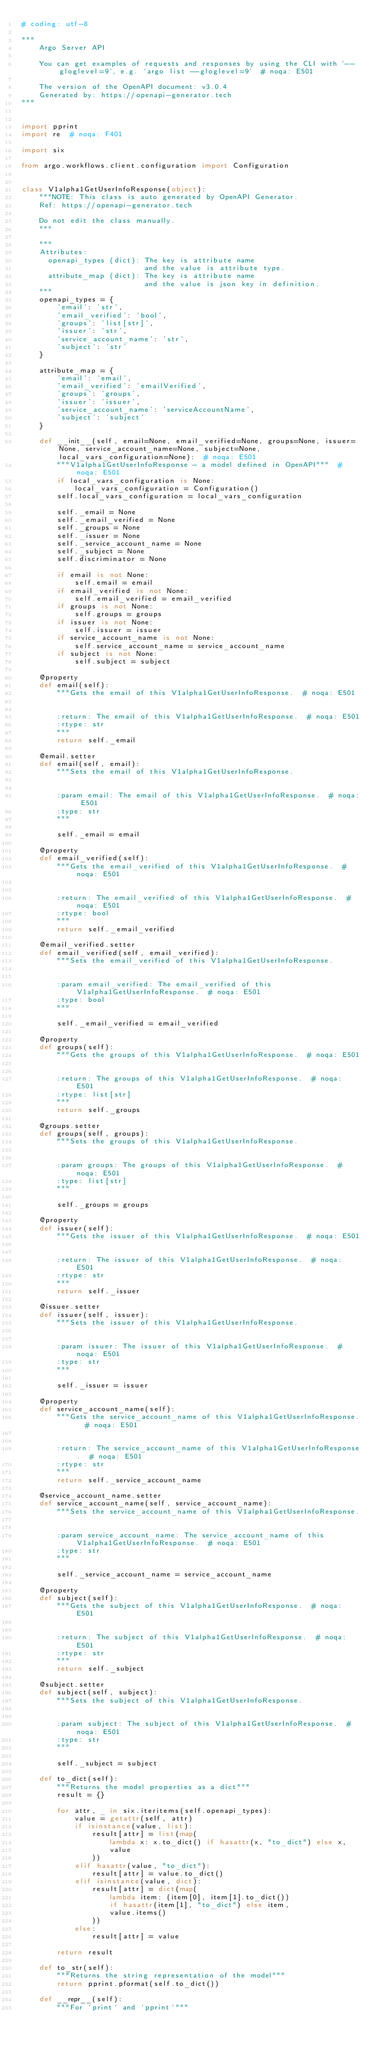Convert code to text. <code><loc_0><loc_0><loc_500><loc_500><_Python_># coding: utf-8

"""
    Argo Server API

    You can get examples of requests and responses by using the CLI with `--gloglevel=9`, e.g. `argo list --gloglevel=9`  # noqa: E501

    The version of the OpenAPI document: v3.0.4
    Generated by: https://openapi-generator.tech
"""


import pprint
import re  # noqa: F401

import six

from argo.workflows.client.configuration import Configuration


class V1alpha1GetUserInfoResponse(object):
    """NOTE: This class is auto generated by OpenAPI Generator.
    Ref: https://openapi-generator.tech

    Do not edit the class manually.
    """

    """
    Attributes:
      openapi_types (dict): The key is attribute name
                            and the value is attribute type.
      attribute_map (dict): The key is attribute name
                            and the value is json key in definition.
    """
    openapi_types = {
        'email': 'str',
        'email_verified': 'bool',
        'groups': 'list[str]',
        'issuer': 'str',
        'service_account_name': 'str',
        'subject': 'str'
    }

    attribute_map = {
        'email': 'email',
        'email_verified': 'emailVerified',
        'groups': 'groups',
        'issuer': 'issuer',
        'service_account_name': 'serviceAccountName',
        'subject': 'subject'
    }

    def __init__(self, email=None, email_verified=None, groups=None, issuer=None, service_account_name=None, subject=None, local_vars_configuration=None):  # noqa: E501
        """V1alpha1GetUserInfoResponse - a model defined in OpenAPI"""  # noqa: E501
        if local_vars_configuration is None:
            local_vars_configuration = Configuration()
        self.local_vars_configuration = local_vars_configuration

        self._email = None
        self._email_verified = None
        self._groups = None
        self._issuer = None
        self._service_account_name = None
        self._subject = None
        self.discriminator = None

        if email is not None:
            self.email = email
        if email_verified is not None:
            self.email_verified = email_verified
        if groups is not None:
            self.groups = groups
        if issuer is not None:
            self.issuer = issuer
        if service_account_name is not None:
            self.service_account_name = service_account_name
        if subject is not None:
            self.subject = subject

    @property
    def email(self):
        """Gets the email of this V1alpha1GetUserInfoResponse.  # noqa: E501


        :return: The email of this V1alpha1GetUserInfoResponse.  # noqa: E501
        :rtype: str
        """
        return self._email

    @email.setter
    def email(self, email):
        """Sets the email of this V1alpha1GetUserInfoResponse.


        :param email: The email of this V1alpha1GetUserInfoResponse.  # noqa: E501
        :type: str
        """

        self._email = email

    @property
    def email_verified(self):
        """Gets the email_verified of this V1alpha1GetUserInfoResponse.  # noqa: E501


        :return: The email_verified of this V1alpha1GetUserInfoResponse.  # noqa: E501
        :rtype: bool
        """
        return self._email_verified

    @email_verified.setter
    def email_verified(self, email_verified):
        """Sets the email_verified of this V1alpha1GetUserInfoResponse.


        :param email_verified: The email_verified of this V1alpha1GetUserInfoResponse.  # noqa: E501
        :type: bool
        """

        self._email_verified = email_verified

    @property
    def groups(self):
        """Gets the groups of this V1alpha1GetUserInfoResponse.  # noqa: E501


        :return: The groups of this V1alpha1GetUserInfoResponse.  # noqa: E501
        :rtype: list[str]
        """
        return self._groups

    @groups.setter
    def groups(self, groups):
        """Sets the groups of this V1alpha1GetUserInfoResponse.


        :param groups: The groups of this V1alpha1GetUserInfoResponse.  # noqa: E501
        :type: list[str]
        """

        self._groups = groups

    @property
    def issuer(self):
        """Gets the issuer of this V1alpha1GetUserInfoResponse.  # noqa: E501


        :return: The issuer of this V1alpha1GetUserInfoResponse.  # noqa: E501
        :rtype: str
        """
        return self._issuer

    @issuer.setter
    def issuer(self, issuer):
        """Sets the issuer of this V1alpha1GetUserInfoResponse.


        :param issuer: The issuer of this V1alpha1GetUserInfoResponse.  # noqa: E501
        :type: str
        """

        self._issuer = issuer

    @property
    def service_account_name(self):
        """Gets the service_account_name of this V1alpha1GetUserInfoResponse.  # noqa: E501


        :return: The service_account_name of this V1alpha1GetUserInfoResponse.  # noqa: E501
        :rtype: str
        """
        return self._service_account_name

    @service_account_name.setter
    def service_account_name(self, service_account_name):
        """Sets the service_account_name of this V1alpha1GetUserInfoResponse.


        :param service_account_name: The service_account_name of this V1alpha1GetUserInfoResponse.  # noqa: E501
        :type: str
        """

        self._service_account_name = service_account_name

    @property
    def subject(self):
        """Gets the subject of this V1alpha1GetUserInfoResponse.  # noqa: E501


        :return: The subject of this V1alpha1GetUserInfoResponse.  # noqa: E501
        :rtype: str
        """
        return self._subject

    @subject.setter
    def subject(self, subject):
        """Sets the subject of this V1alpha1GetUserInfoResponse.


        :param subject: The subject of this V1alpha1GetUserInfoResponse.  # noqa: E501
        :type: str
        """

        self._subject = subject

    def to_dict(self):
        """Returns the model properties as a dict"""
        result = {}

        for attr, _ in six.iteritems(self.openapi_types):
            value = getattr(self, attr)
            if isinstance(value, list):
                result[attr] = list(map(
                    lambda x: x.to_dict() if hasattr(x, "to_dict") else x,
                    value
                ))
            elif hasattr(value, "to_dict"):
                result[attr] = value.to_dict()
            elif isinstance(value, dict):
                result[attr] = dict(map(
                    lambda item: (item[0], item[1].to_dict())
                    if hasattr(item[1], "to_dict") else item,
                    value.items()
                ))
            else:
                result[attr] = value

        return result

    def to_str(self):
        """Returns the string representation of the model"""
        return pprint.pformat(self.to_dict())

    def __repr__(self):
        """For `print` and `pprint`"""</code> 